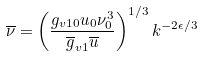Convert formula to latex. <formula><loc_0><loc_0><loc_500><loc_500>\overline { \nu } = \left ( \frac { g _ { v 1 0 } u _ { 0 } \nu _ { 0 } ^ { 3 } } { { \overline { g } } _ { v 1 } \overline { u } } \right ) ^ { 1 / 3 } k ^ { - 2 \epsilon / 3 }</formula> 